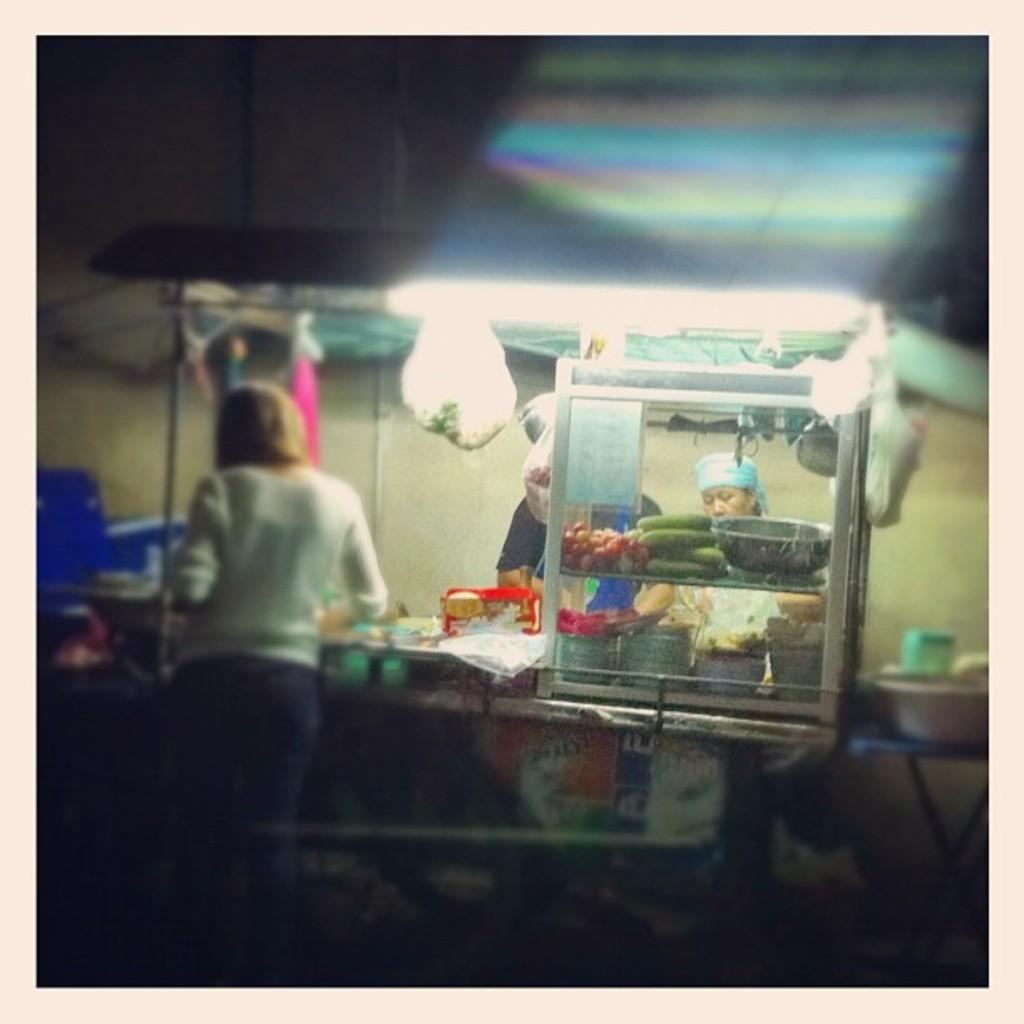How many people are present in the image? There are three persons standing in the image. What type of food items can be seen in the image? There are vegetables in the image. What is used to hold the food items? There is a bowl and a plate in the image. What is used to cover the food items? There are plastic covers in the image. What is the primary surface on which the food items are placed? There is a table in the image. What can be seen in the background of the image? There is a wall in the background of the image. What type of clover is growing on the edge of the table in the image? There is no clover present in the image, and the table's edge is not visible. What type of polish is being used on the wall in the image? There is no indication of any polish being used on the wall in the image. 